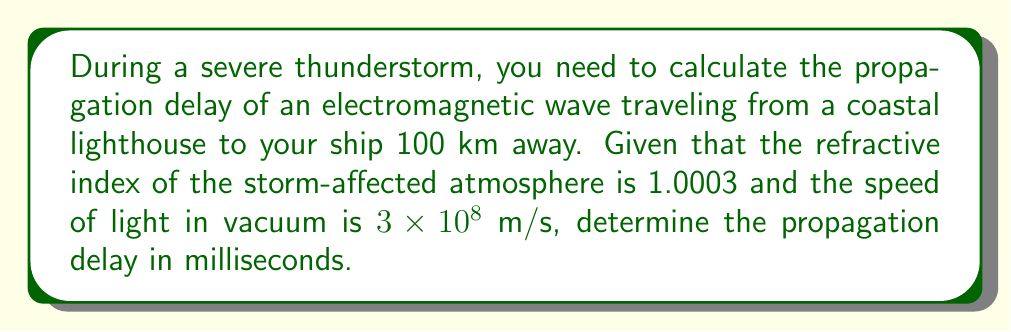Could you help me with this problem? To solve this problem, we'll follow these steps:

1) First, recall that the speed of light in a medium is given by:
   $$ v = \frac{c}{n} $$
   where $v$ is the speed in the medium, $c$ is the speed of light in vacuum, and $n$ is the refractive index.

2) Calculate the speed of the electromagnetic wave in the storm-affected atmosphere:
   $$ v = \frac{3 \times 10^8}{1.0003} = 2.9991 \times 10^8 \text{ m/s} $$

3) The propagation delay is the time it takes for the wave to travel the given distance. We can calculate this using the distance formula:
   $$ t = \frac{d}{v} $$
   where $t$ is time, $d$ is distance, and $v$ is velocity.

4) Plug in the values:
   $$ t = \frac{100 \times 10^3 \text{ m}}{2.9991 \times 10^8 \text{ m/s}} = 3.3344 \times 10^{-4} \text{ s} $$

5) Convert the result to milliseconds:
   $$ 3.3344 \times 10^{-4} \text{ s} \times \frac{1000 \text{ ms}}{1 \text{ s}} = 0.3334 \text{ ms} $$

Therefore, the propagation delay is approximately 0.3334 milliseconds.
Answer: 0.3334 ms 